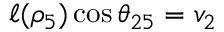Convert formula to latex. <formula><loc_0><loc_0><loc_500><loc_500>\ell ( \rho _ { 5 } ) \cos \theta _ { 2 5 } = v _ { 2 }</formula> 